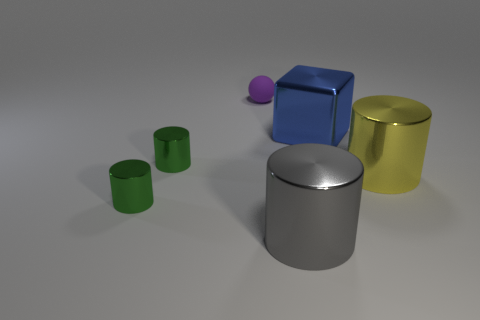Subtract all green cylinders. How many cylinders are left? 2 Add 1 tiny red rubber cylinders. How many objects exist? 7 Subtract 1 cylinders. How many cylinders are left? 3 Subtract all yellow cylinders. Subtract all purple blocks. How many cylinders are left? 3 Subtract all spheres. How many objects are left? 5 Subtract all red cylinders. How many red spheres are left? 0 Subtract all tiny red objects. Subtract all rubber balls. How many objects are left? 5 Add 5 small things. How many small things are left? 8 Add 6 tiny objects. How many tiny objects exist? 9 Subtract 0 cyan cubes. How many objects are left? 6 